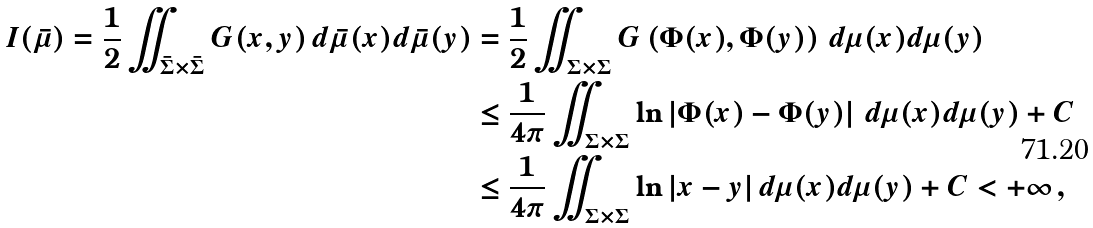<formula> <loc_0><loc_0><loc_500><loc_500>I ( \bar { \mu } ) = \frac { 1 } { 2 } \iint _ { \bar { \Sigma } \times \bar { \Sigma } } G ( x , y ) \, d \bar { \mu } ( x ) d \bar { \mu } ( y ) & = \frac { 1 } { 2 } \iint _ { \Sigma \times \Sigma } G \left ( \Phi ( x ) , \Phi ( y ) \right ) \, d \mu ( x ) d \mu ( y ) \\ & \leq \frac { 1 } { 4 \pi } \iint _ { \Sigma \times \Sigma } \ln \left | \Phi ( x ) - \Phi ( y ) \right | \, d \mu ( x ) d \mu ( y ) + C \\ & \leq \frac { 1 } { 4 \pi } \iint _ { \Sigma \times \Sigma } \ln | x - y | \, d \mu ( x ) d \mu ( y ) + C < + \infty \, ,</formula> 